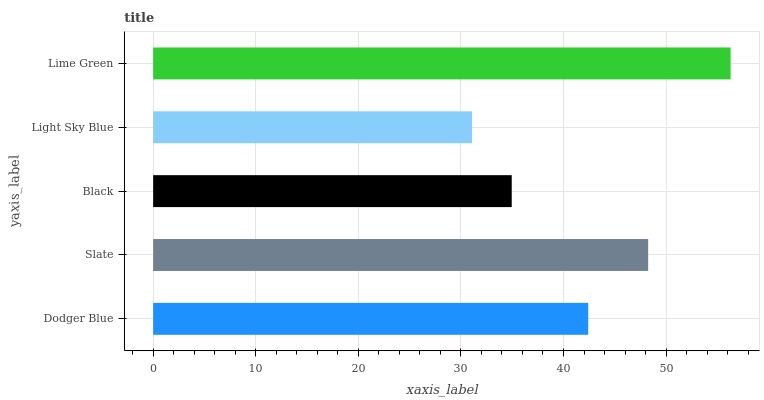Is Light Sky Blue the minimum?
Answer yes or no. Yes. Is Lime Green the maximum?
Answer yes or no. Yes. Is Slate the minimum?
Answer yes or no. No. Is Slate the maximum?
Answer yes or no. No. Is Slate greater than Dodger Blue?
Answer yes or no. Yes. Is Dodger Blue less than Slate?
Answer yes or no. Yes. Is Dodger Blue greater than Slate?
Answer yes or no. No. Is Slate less than Dodger Blue?
Answer yes or no. No. Is Dodger Blue the high median?
Answer yes or no. Yes. Is Dodger Blue the low median?
Answer yes or no. Yes. Is Black the high median?
Answer yes or no. No. Is Light Sky Blue the low median?
Answer yes or no. No. 